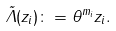<formula> <loc_0><loc_0><loc_500><loc_500>\tilde { \Lambda } ( z _ { i } ) \colon = \theta ^ { m _ { i } } z _ { i } .</formula> 